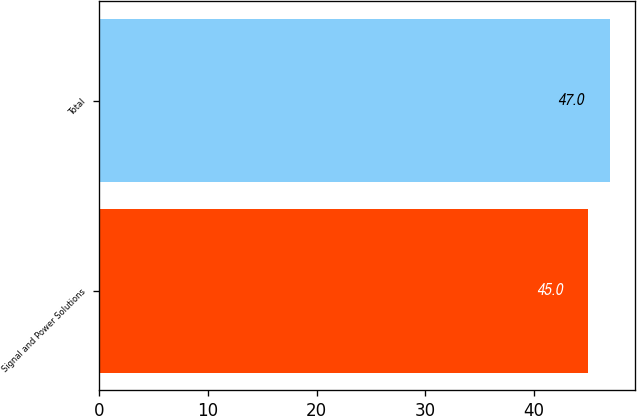Convert chart to OTSL. <chart><loc_0><loc_0><loc_500><loc_500><bar_chart><fcel>Signal and Power Solutions<fcel>Total<nl><fcel>45<fcel>47<nl></chart> 